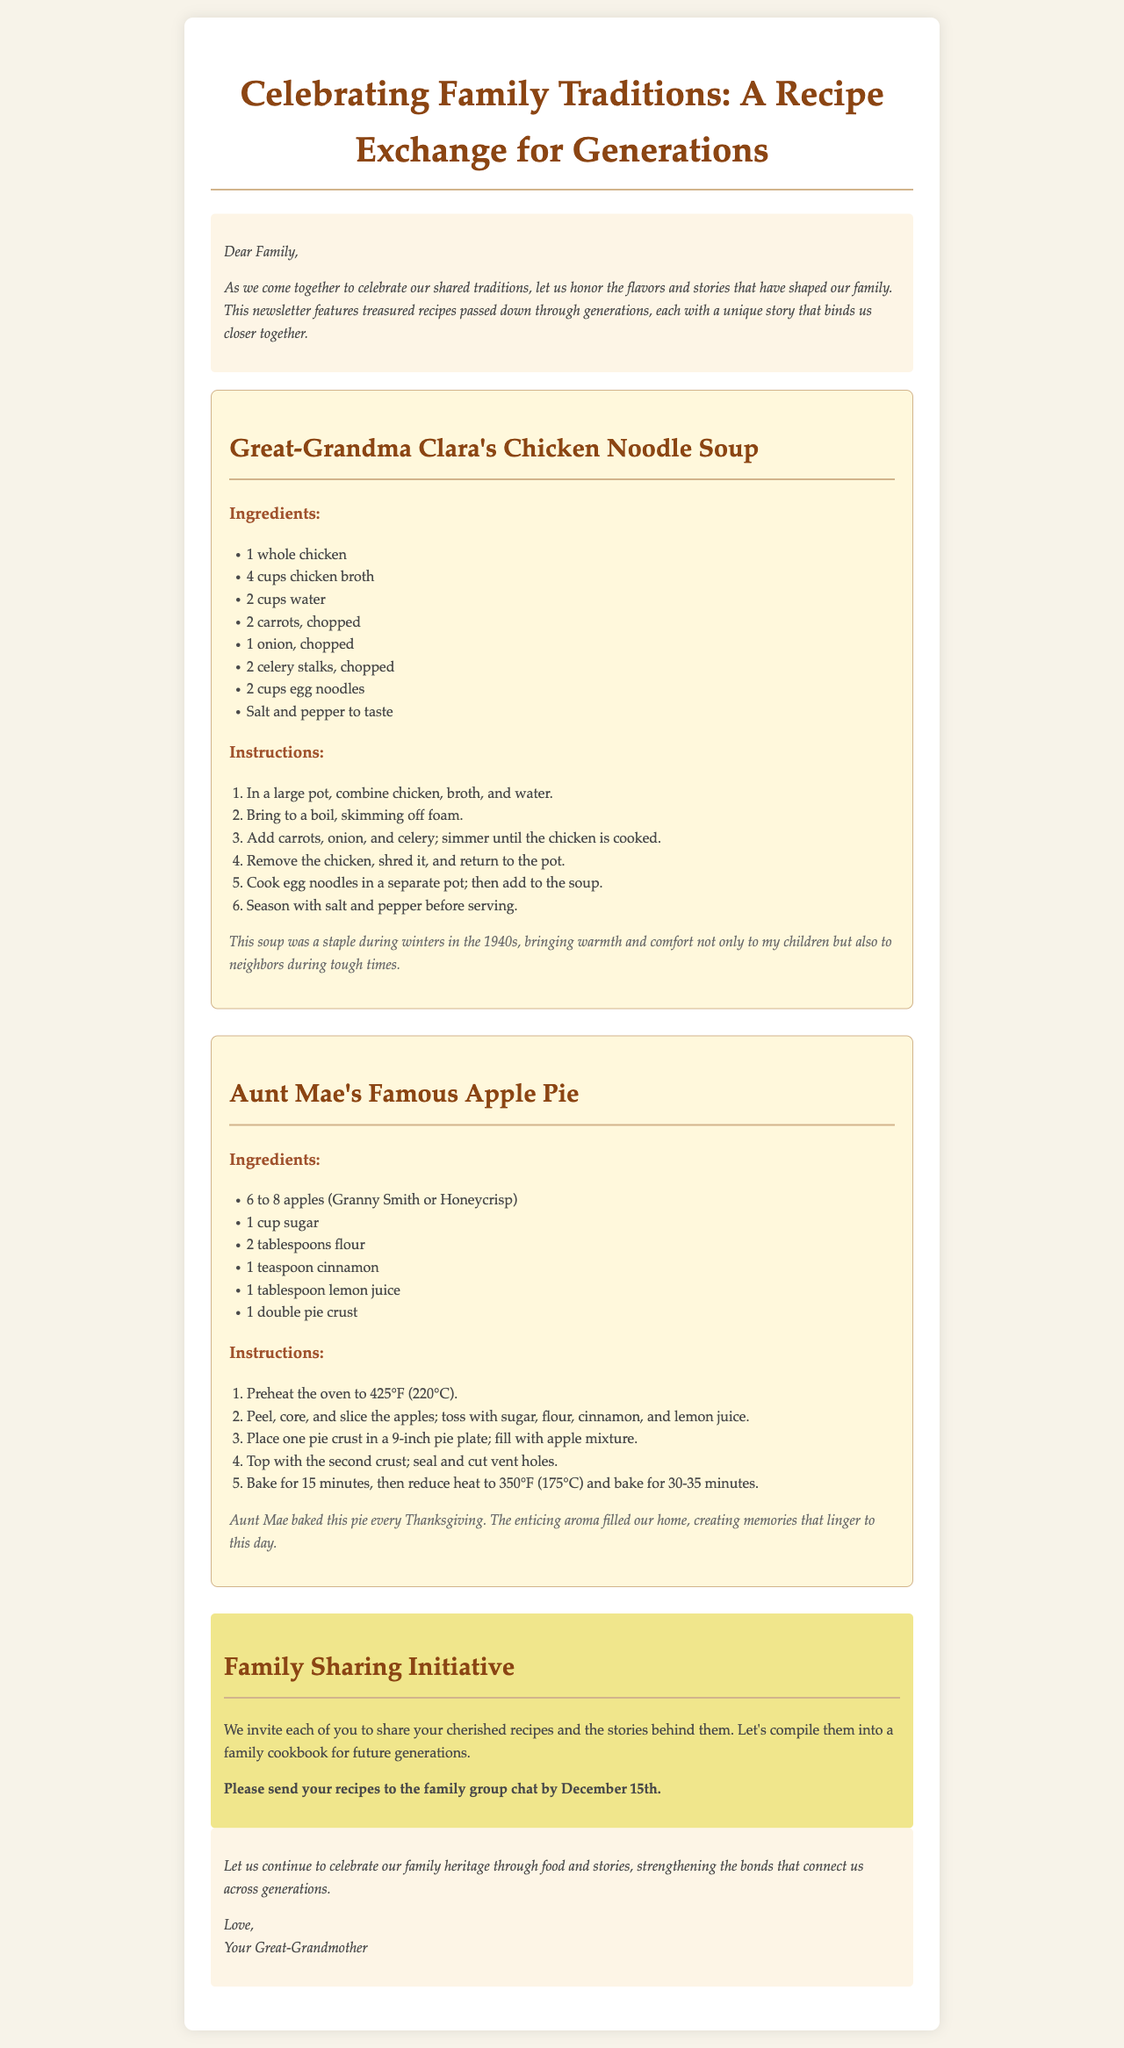what is the title of the newsletter? The title of the newsletter is prominently displayed at the top of the document.
Answer: Celebrating Family Traditions: A Recipe Exchange for Generations who contributed the Chicken Noodle Soup recipe? The recipe is attributed to Great-Grandma Clara, indicating her contribution.
Answer: Great-Grandma Clara how many apples are needed for Aunt Mae's Famous Apple Pie? The ingredients list specifies the quantity of apples needed for the pie.
Answer: 6 to 8 apples what is the cooking time for Aunt Mae’s Famous Apple Pie? The instructions provide specific cooking times at different temperatures.
Answer: 45-50 minutes what is the purpose of the Family Sharing Initiative? The section outlines an invitation for family members to share their recipes and stories.
Answer: To compile recipes into a family cookbook in which decade was Great-Grandma Clara’s chicken noodle soup a staple? The document references a specific timeframe for this recipe's significance.
Answer: 1940s what should family members do by December 15th? The document contains a clear call to action with a deadline.
Answer: Send recipes to the family group chat what does the closing statement encourage? The conclusion suggests a focus on family heritage through specific means.
Answer: Celebrate our family heritage through food and stories 